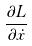<formula> <loc_0><loc_0><loc_500><loc_500>\frac { \partial L } { \partial \dot { x } }</formula> 